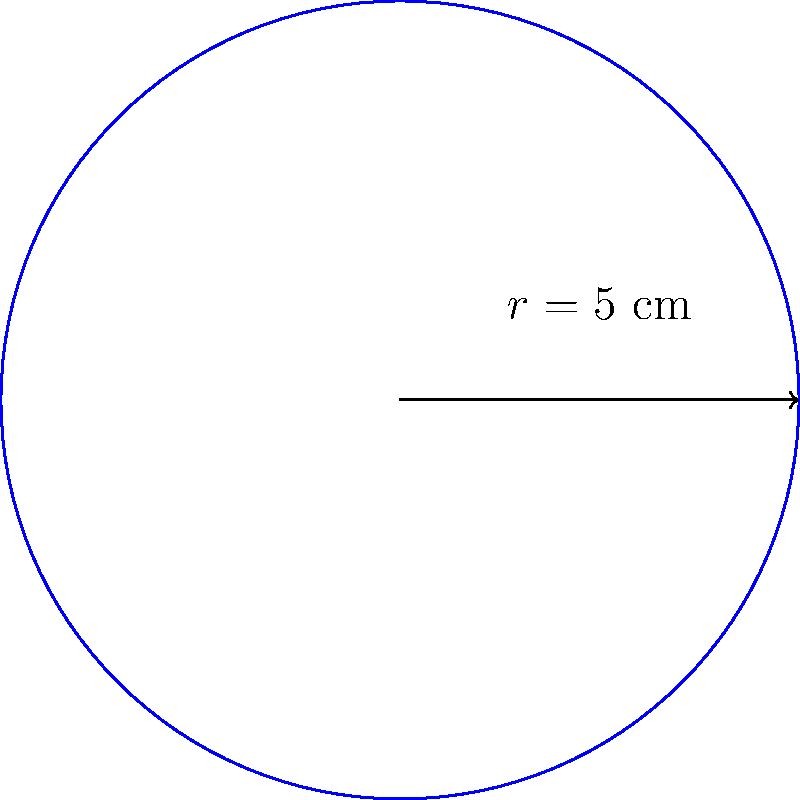As a cobbler, you often use circular shoe polish tins. You have a new tin with a radius of 5 cm. What is the area of the circular base of this tin? (Use $\pi \approx 3.14$) To find the area of a circular shoe polish tin, we need to use the formula for the area of a circle:

1. The formula for the area of a circle is $A = \pi r^2$, where $A$ is the area and $r$ is the radius.

2. We are given that the radius $r = 5$ cm.

3. Substituting the values into the formula:
   $A = \pi \times 5^2$

4. Simplify the exponent:
   $A = \pi \times 25$

5. Using $\pi \approx 3.14$:
   $A \approx 3.14 \times 25$

6. Calculate the final result:
   $A \approx 78.5$ cm²

Therefore, the area of the circular base of the shoe polish tin is approximately 78.5 square centimeters.
Answer: $78.5$ cm² 